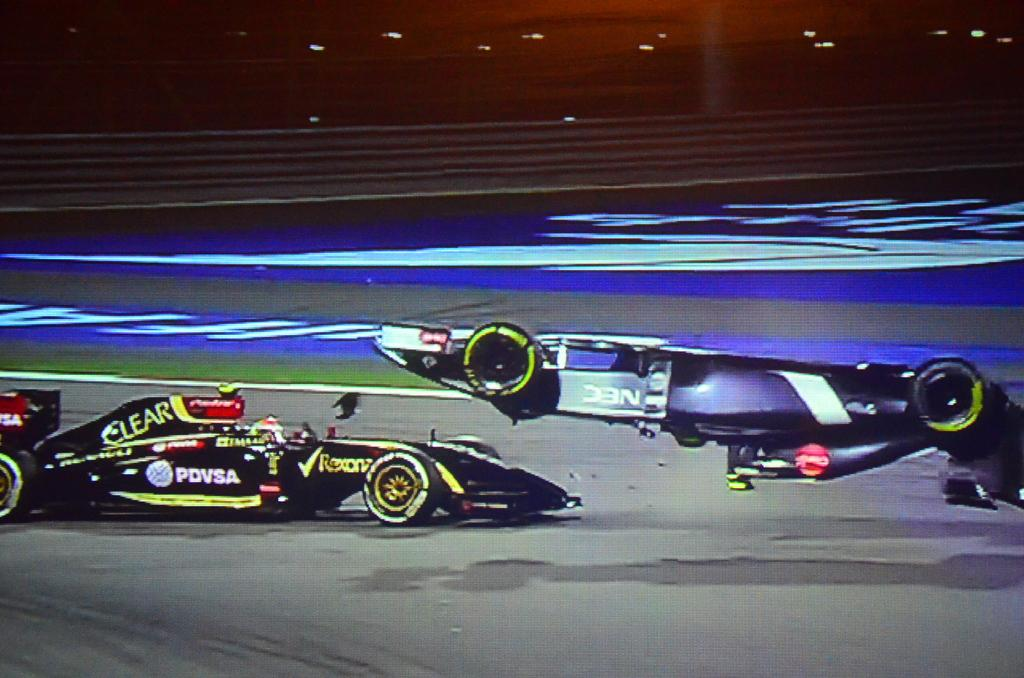How many cars are visible in the image? There are two cars in the image. Where are the cars located? The cars are on the road. What flavor of powder is being used to mark the territory of the cars in the image? There is no powder or territory marking present in the image; it simply shows two cars on the road. 